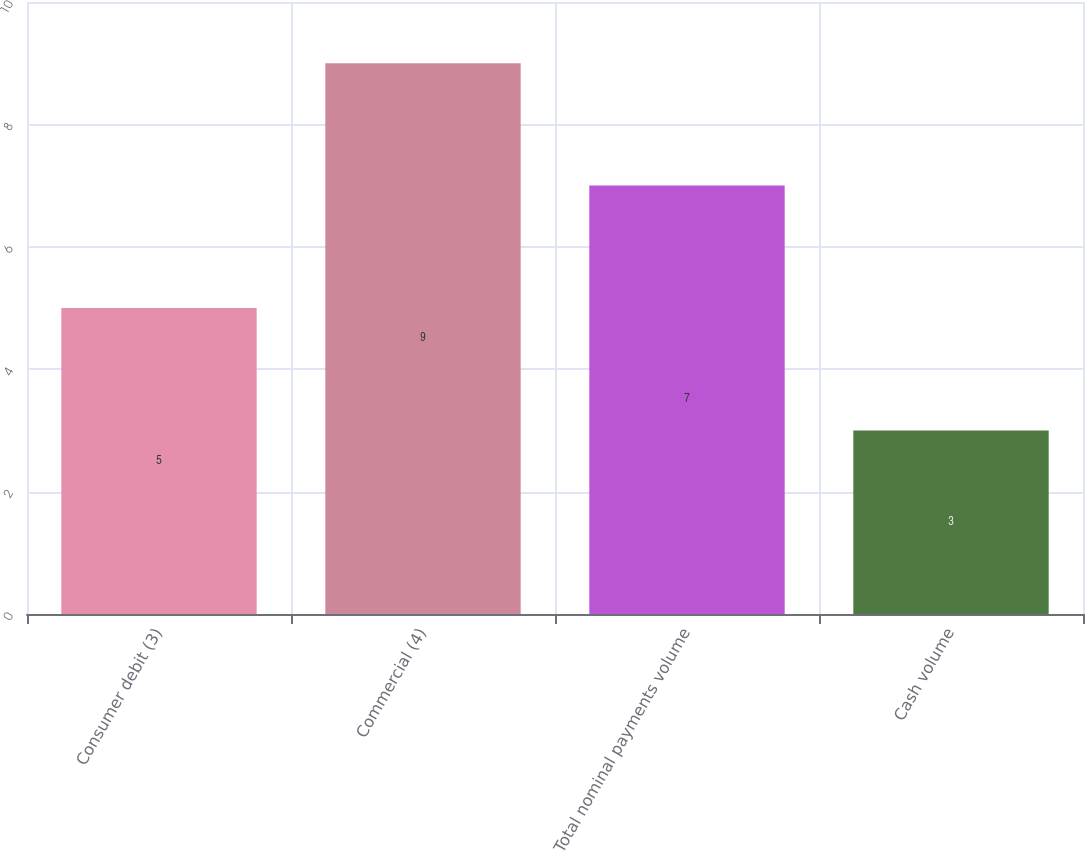Convert chart. <chart><loc_0><loc_0><loc_500><loc_500><bar_chart><fcel>Consumer debit (3)<fcel>Commercial (4)<fcel>Total nominal payments volume<fcel>Cash volume<nl><fcel>5<fcel>9<fcel>7<fcel>3<nl></chart> 